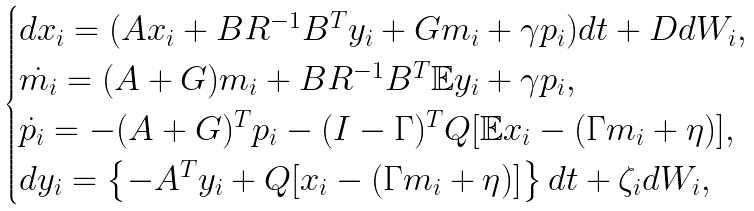Convert formula to latex. <formula><loc_0><loc_0><loc_500><loc_500>\begin{cases} d x _ { i } = ( A x _ { i } + B R ^ { - 1 } B ^ { T } y _ { i } + G m _ { i } + \gamma p _ { i } ) d t + D d W _ { i } , \\ \dot { m _ { i } } = ( A + G ) m _ { i } + B R ^ { - 1 } B ^ { T } { \mathbb { E } } y _ { i } + \gamma p _ { i } , \\ \dot { p _ { i } } = - ( A + G ) ^ { T } p _ { i } - ( I - \Gamma ) ^ { T } Q [ \mathbb { E } x _ { i } - ( \Gamma m _ { i } + \eta ) ] , \\ d y _ { i } = \left \{ - A ^ { T } y _ { i } + Q [ x _ { i } - ( \Gamma m _ { i } + \eta ) ] \right \} d t + \zeta _ { i } d W _ { i } , \end{cases}</formula> 